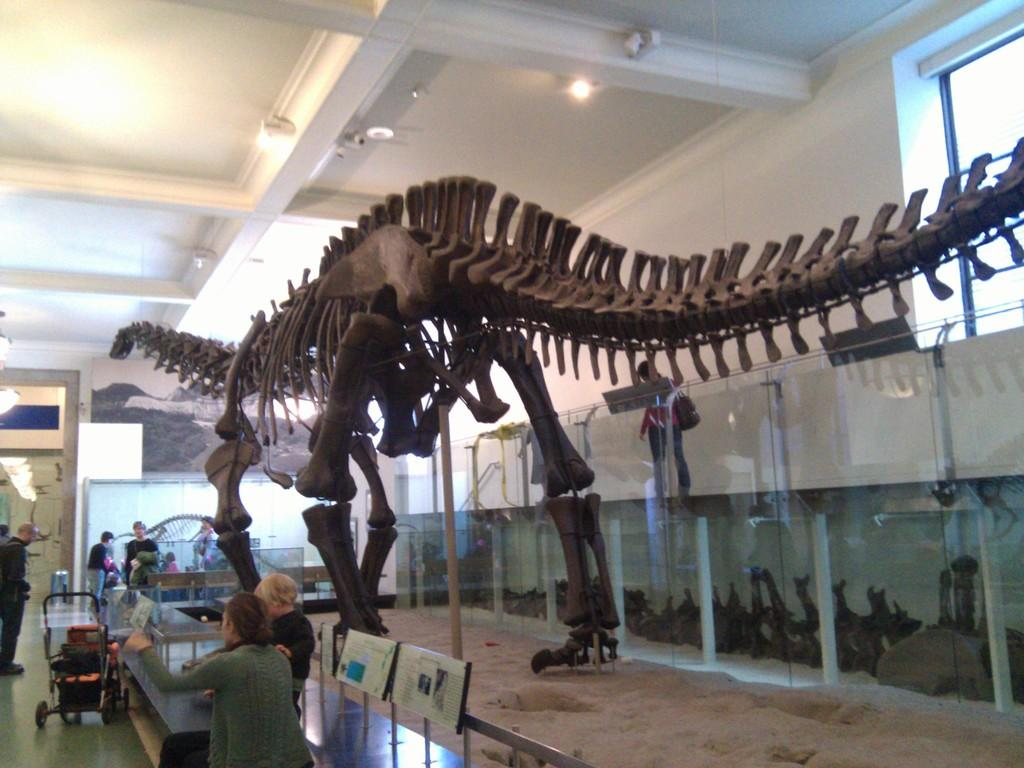What is the main subject of the image? The main subject of the image is a skeleton of an animal. Are there any people present in the image? Yes, there are people in the image. What type of structures can be seen in the image? There are boards, glass walls, windows, and a wall visible in the image. What other objects can be seen in the image? There are lights and a trolley present in the image. What type of sponge is being used to clean the animal's toe in the image? There is no sponge or cleaning activity involving an animal's toe present in the image. 